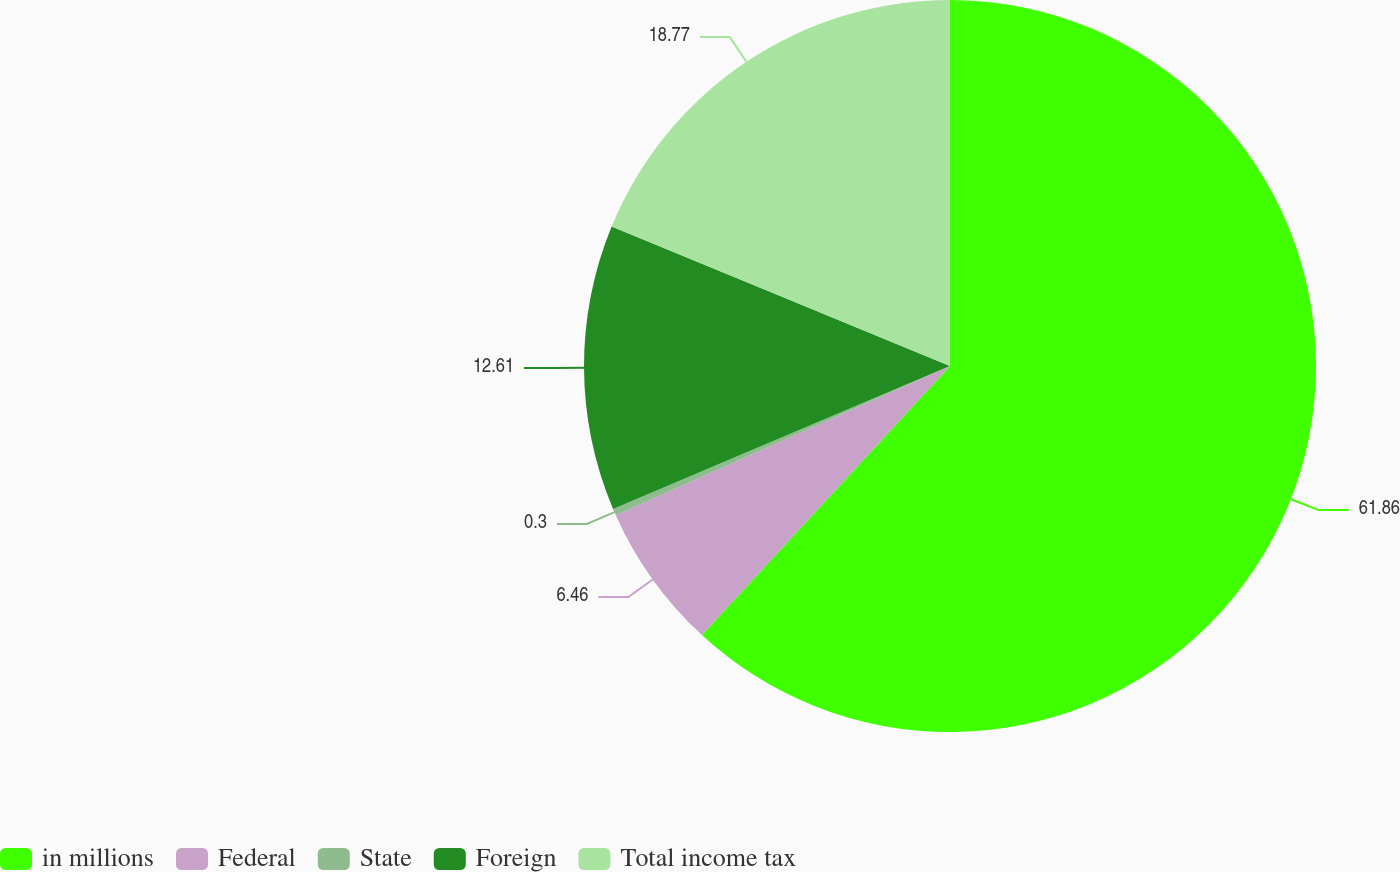Convert chart to OTSL. <chart><loc_0><loc_0><loc_500><loc_500><pie_chart><fcel>in millions<fcel>Federal<fcel>State<fcel>Foreign<fcel>Total income tax<nl><fcel>61.85%<fcel>6.46%<fcel>0.3%<fcel>12.61%<fcel>18.77%<nl></chart> 